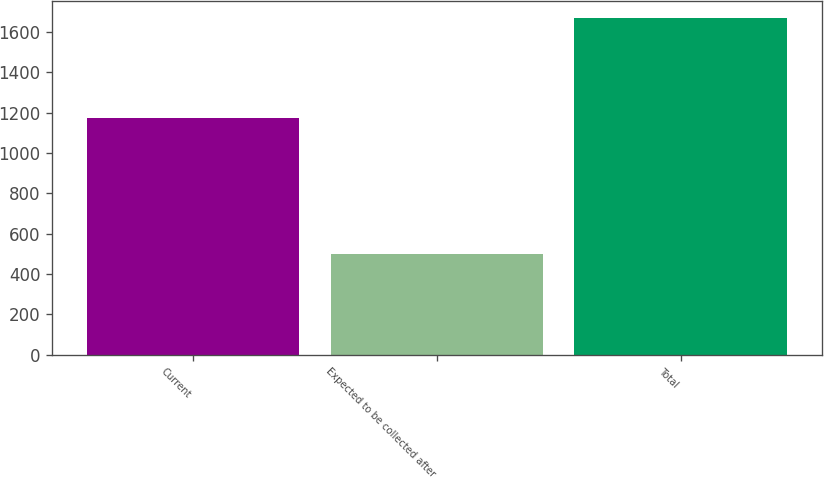Convert chart. <chart><loc_0><loc_0><loc_500><loc_500><bar_chart><fcel>Current<fcel>Expected to be collected after<fcel>Total<nl><fcel>1174<fcel>498<fcel>1672<nl></chart> 